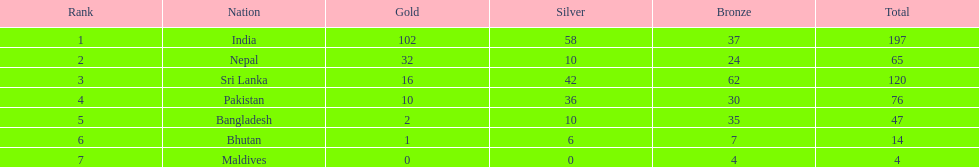What is the count of gold medals that india has achieved? 102. 